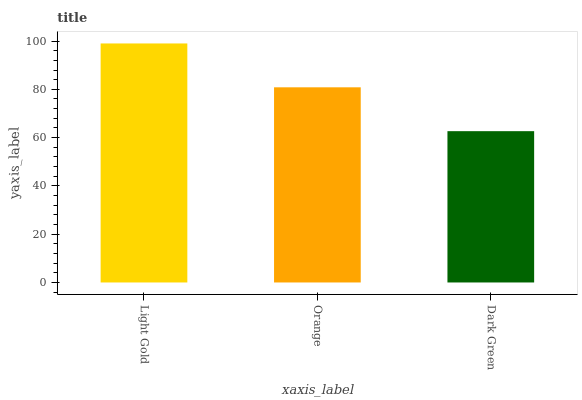Is Dark Green the minimum?
Answer yes or no. Yes. Is Light Gold the maximum?
Answer yes or no. Yes. Is Orange the minimum?
Answer yes or no. No. Is Orange the maximum?
Answer yes or no. No. Is Light Gold greater than Orange?
Answer yes or no. Yes. Is Orange less than Light Gold?
Answer yes or no. Yes. Is Orange greater than Light Gold?
Answer yes or no. No. Is Light Gold less than Orange?
Answer yes or no. No. Is Orange the high median?
Answer yes or no. Yes. Is Orange the low median?
Answer yes or no. Yes. Is Dark Green the high median?
Answer yes or no. No. Is Light Gold the low median?
Answer yes or no. No. 